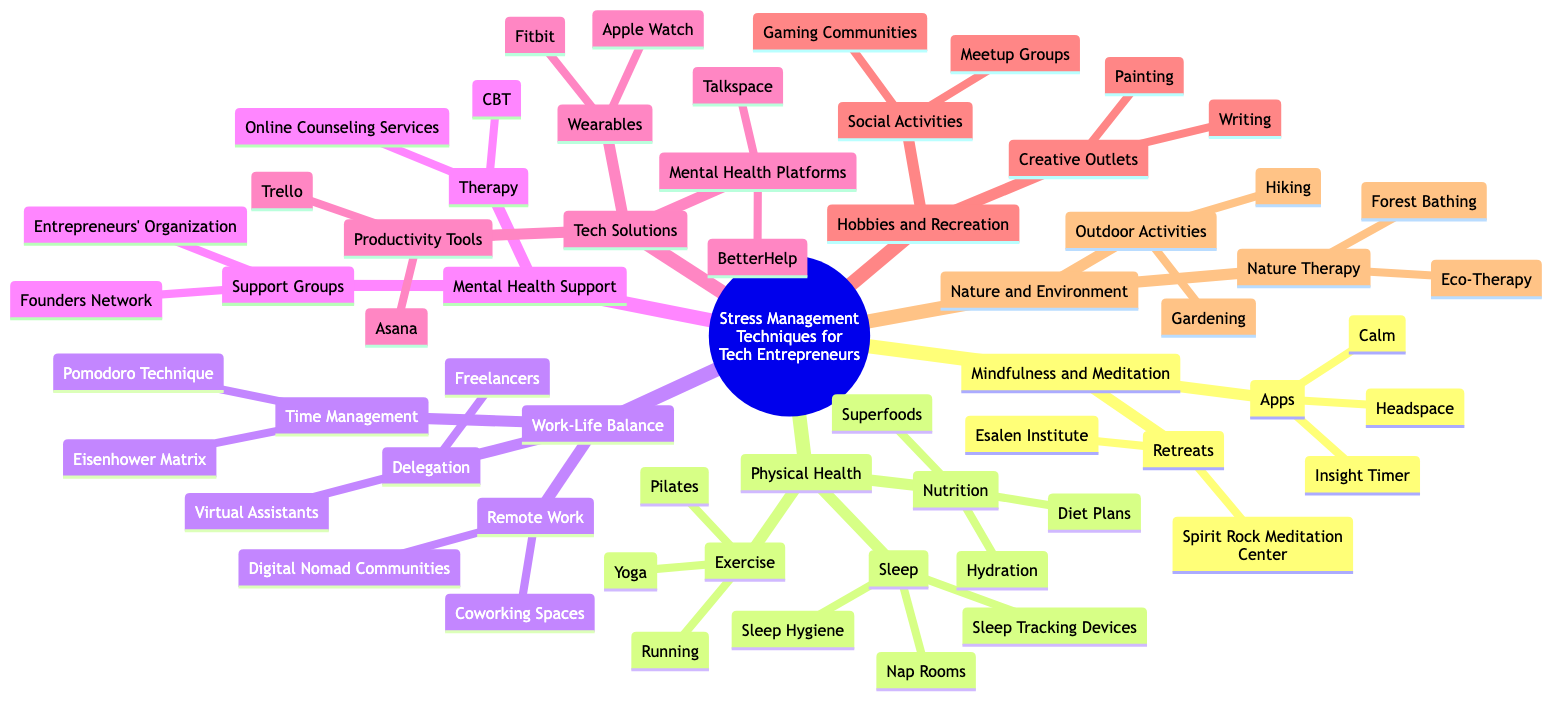What are the apps listed under Mindfulness and Meditation? The diagram specifically names three apps under the "Apps" node in the "Mindfulness and Meditation" section: Headspace, Calm, and Insight Timer.
Answer: Headspace, Calm, Insight Timer How many categories are listed for Physical Health? In the diagram, the "Physical Health" category contains three distinct subcategories: Exercise, Nutrition, and Sleep. Thus, there are three categories.
Answer: 3 What technique is associated with Time Management? The diagram indicates the "Pomodoro Technique" and "Eisenhower Matrix" as the specific techniques listed under the "Time Management" node within the "Work-Life Balance" category.
Answer: Pomodoro Technique, Eisenhower Matrix Which support group is related to mental health? According to the diagram, the "Entrepreneurs' Organization" and "Founders Network" are the specified support groups listed in the "Mental Health Support" section.
Answer: Entrepreneurs' Organization, Founders Network How many outdoor activities are mentioned in Nature and Environment? Under the "Outdoor Activities" node within the "Nature and Environment" category, the diagram lists two specific activities: Hiking and Gardening, resulting in a count of two outdoor activities.
Answer: 2 Which wearable devices are mentioned? The diagram lists two wearable devices in the "Wearables" section of "Tech Solutions": Fitbit and Apple Watch.
Answer: Fitbit, Apple Watch What is a recommended creative outlet? The diagram points to "Painting" and "Writing" as creative outlets listed under the "Creative Outlets" node in the "Hobbies and Recreation" category.
Answer: Painting, Writing What is the relationship between work-life balance and remote work? The relationship is that "Remote Work" is a subcategory of "Work-Life Balance", indicating that remote work strategies can contribute to achieving balance in work and life.
Answer: Remote Work is a subcategory of Work-Life Balance How many techniques are listed under Therapy in Mental Health Support? The section "Therapy" under "Mental Health Support" displays two techniques: Cognitive Behavioral Therapy (CBT) and Online Counseling Services, making a total of two techniques.
Answer: 2 